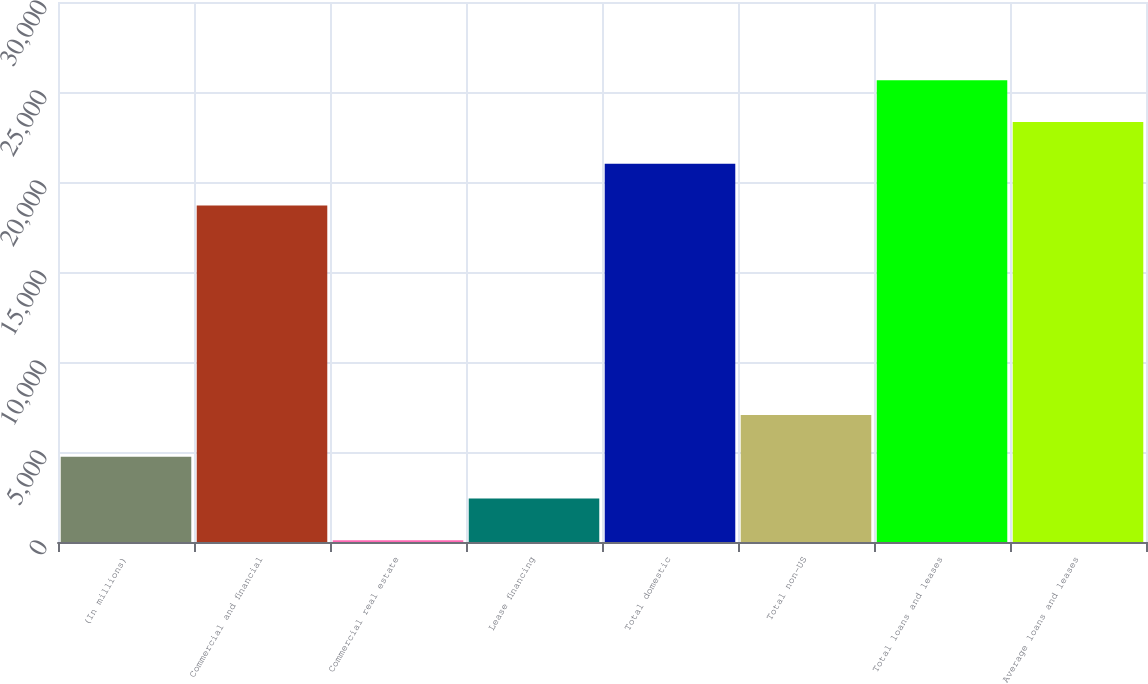Convert chart to OTSL. <chart><loc_0><loc_0><loc_500><loc_500><bar_chart><fcel>(In millions)<fcel>Commercial and financial<fcel>Commercial real estate<fcel>Lease financing<fcel>Total domestic<fcel>Total non-US<fcel>Total loans and leases<fcel>Average loans and leases<nl><fcel>4737.2<fcel>18696<fcel>98<fcel>2417.6<fcel>21015.6<fcel>7056.8<fcel>25654.8<fcel>23335.2<nl></chart> 